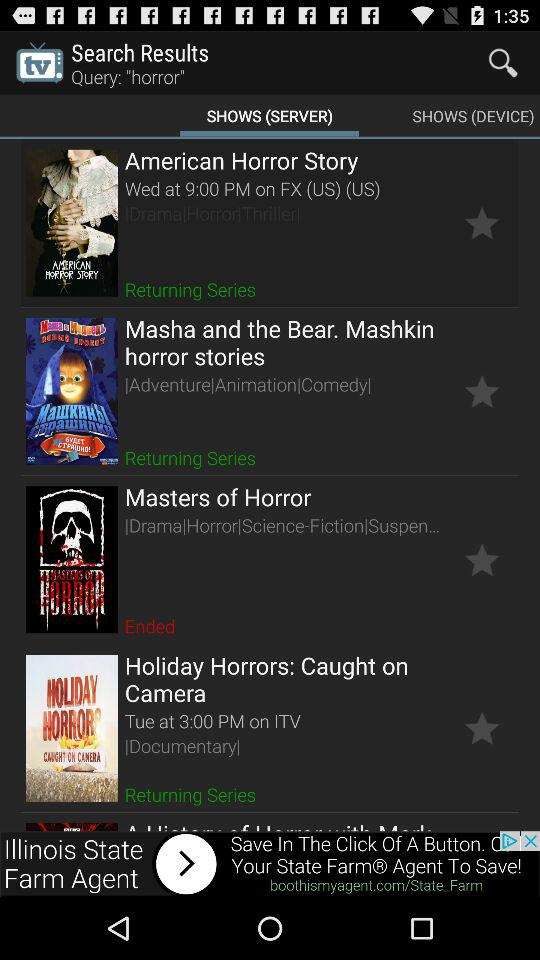Which show has ended? The show is "Masters of Horror". 